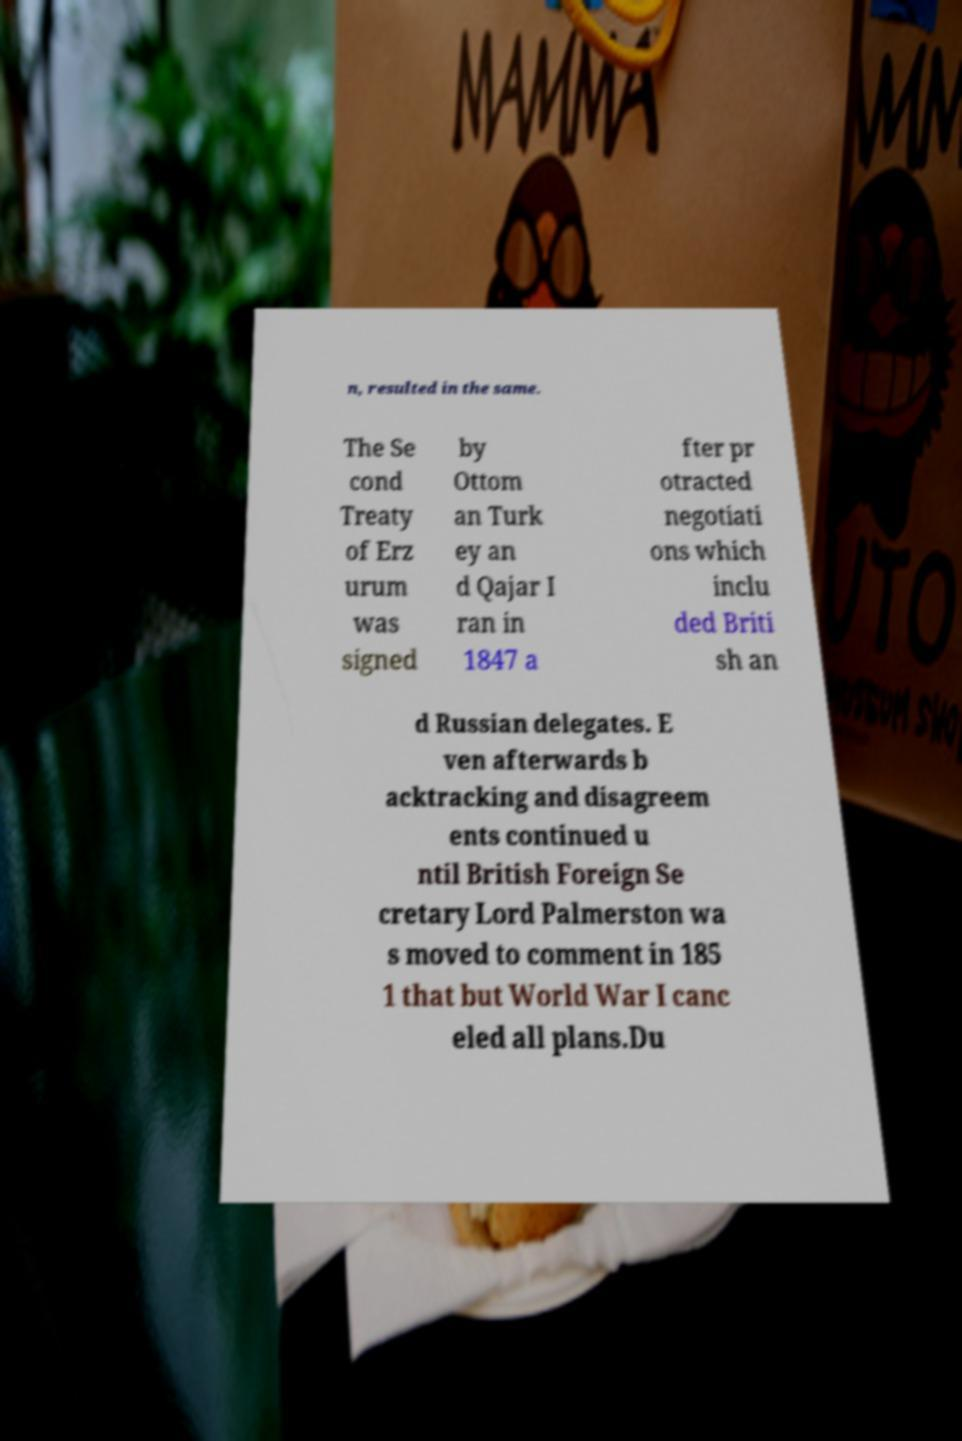For documentation purposes, I need the text within this image transcribed. Could you provide that? n, resulted in the same. The Se cond Treaty of Erz urum was signed by Ottom an Turk ey an d Qajar I ran in 1847 a fter pr otracted negotiati ons which inclu ded Briti sh an d Russian delegates. E ven afterwards b acktracking and disagreem ents continued u ntil British Foreign Se cretary Lord Palmerston wa s moved to comment in 185 1 that but World War I canc eled all plans.Du 